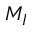<formula> <loc_0><loc_0><loc_500><loc_500>M _ { I }</formula> 